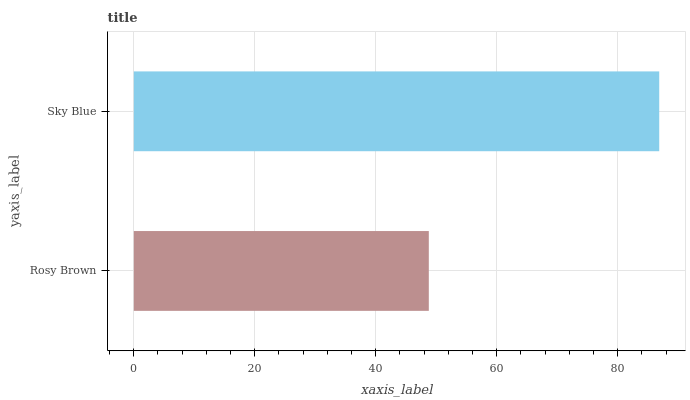Is Rosy Brown the minimum?
Answer yes or no. Yes. Is Sky Blue the maximum?
Answer yes or no. Yes. Is Sky Blue the minimum?
Answer yes or no. No. Is Sky Blue greater than Rosy Brown?
Answer yes or no. Yes. Is Rosy Brown less than Sky Blue?
Answer yes or no. Yes. Is Rosy Brown greater than Sky Blue?
Answer yes or no. No. Is Sky Blue less than Rosy Brown?
Answer yes or no. No. Is Sky Blue the high median?
Answer yes or no. Yes. Is Rosy Brown the low median?
Answer yes or no. Yes. Is Rosy Brown the high median?
Answer yes or no. No. Is Sky Blue the low median?
Answer yes or no. No. 